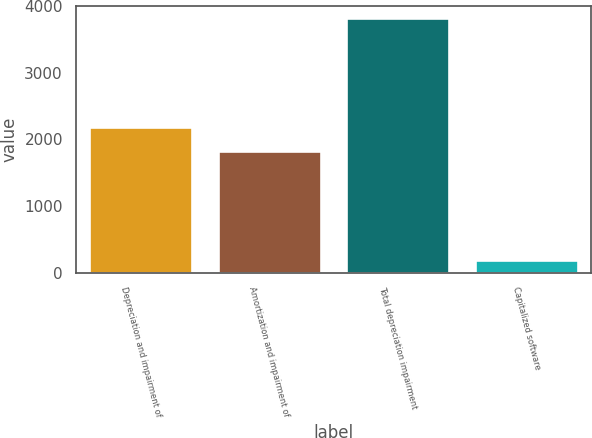Convert chart. <chart><loc_0><loc_0><loc_500><loc_500><bar_chart><fcel>Depreciation and impairment of<fcel>Amortization and impairment of<fcel>Total depreciation impairment<fcel>Capitalized software<nl><fcel>2187.9<fcel>1826<fcel>3814<fcel>195<nl></chart> 